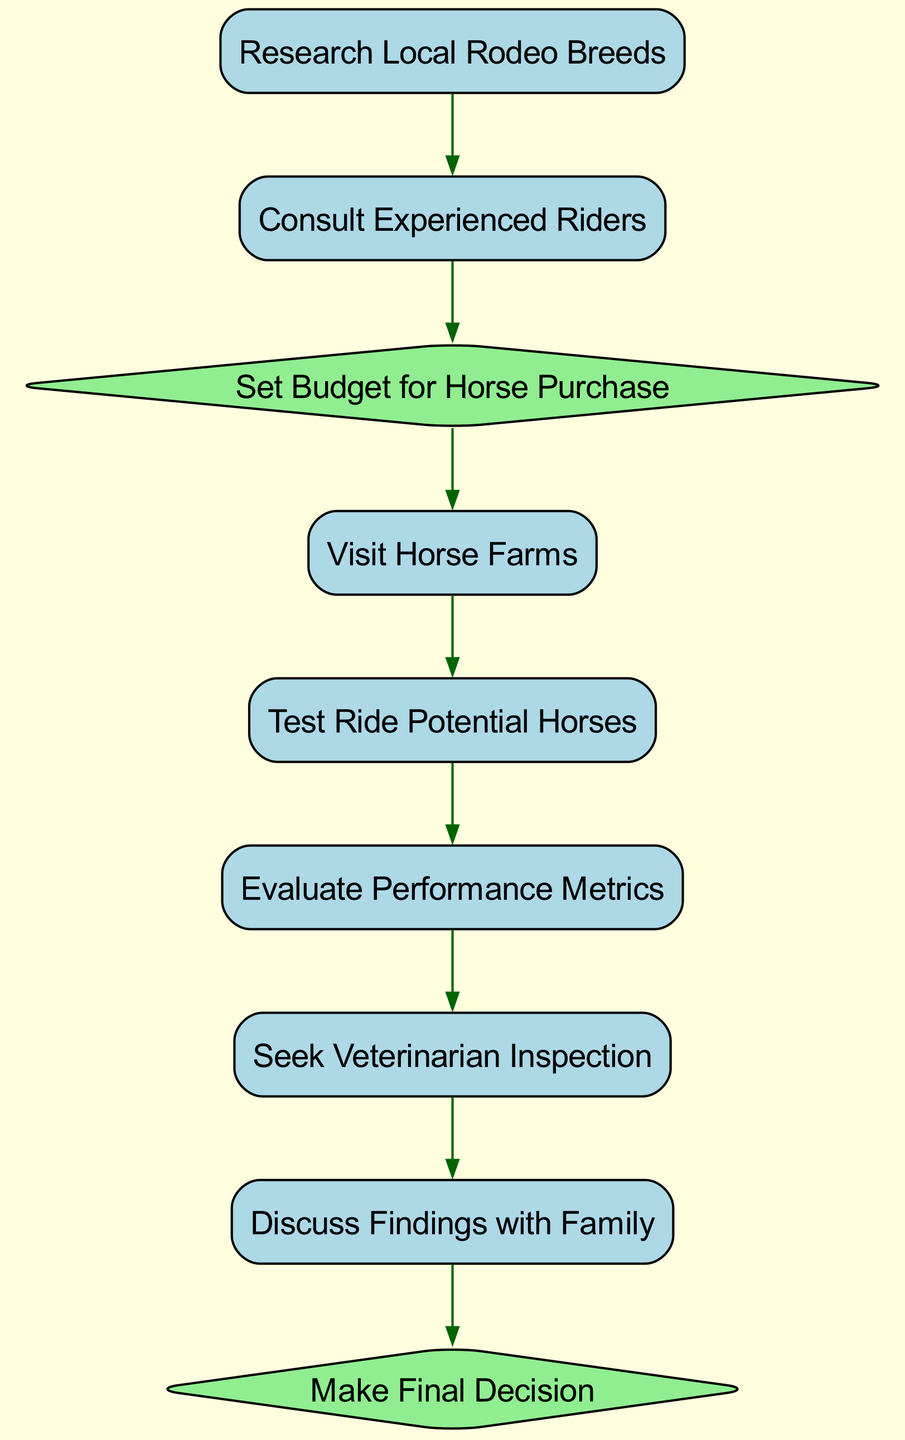What is the first activity in the selection process? The first activity listed in the diagram is "Research Local Rodeo Breeds." It appears at the top of the sequence, indicating it is the starting point.
Answer: Research Local Rodeo Breeds How many decision nodes are present in the diagram? The diagram includes two decision nodes: "Set Budget for Horse Purchase" and "Make Final Decision." Counting these gives us the total number of decision points in the process.
Answer: 2 What activity follows "Consult Experienced Riders"? The activity that follows "Consult Experienced Riders" is "Set Budget for Horse Purchase." By observing the order of nodes from the top down, we can identify the next step in the process.
Answer: Set Budget for Horse Purchase Which activity is last in the sequence? The last activity in the sequence is "Make Final Decision." It is positioned at the end of the flow, indicating that it completes the process.
Answer: Make Final Decision What are the activities performed after the budget decision? After the budget decision, the activities performed are "Visit Horse Farms," "Test Ride Potential Horses," "Evaluate Performance Metrics," and "Seek Veterinarian Inspection." These activities logically follow the decision to set a budget.
Answer: Visit Horse Farms, Test Ride Potential Horses, Evaluate Performance Metrics, Seek Veterinarian Inspection Which decision leads to the final decision? The decision that leads to the final decision is "Discuss Findings with Family," as it also occurs just before the final decision is made in the sequence of events.
Answer: Discuss Findings with Family What is the relationship between "Evaluate Performance Metrics" and "Seek Veterinarian Inspection"? The relationship is sequential; "Evaluate Performance Metrics" occurs before "Seek Veterinarian Inspection." This ordering shows that evaluating metrics is necessary before getting a vet's opinion on the horse.
Answer: Sequential What type of nodes can be found in this diagram? The diagram contains two types of nodes: activity nodes and decision nodes. Activities are represented by rectangles, while decisions are depicted as diamonds. This distinction categorizes the steps involved in the process.
Answer: Activity nodes and decision nodes 